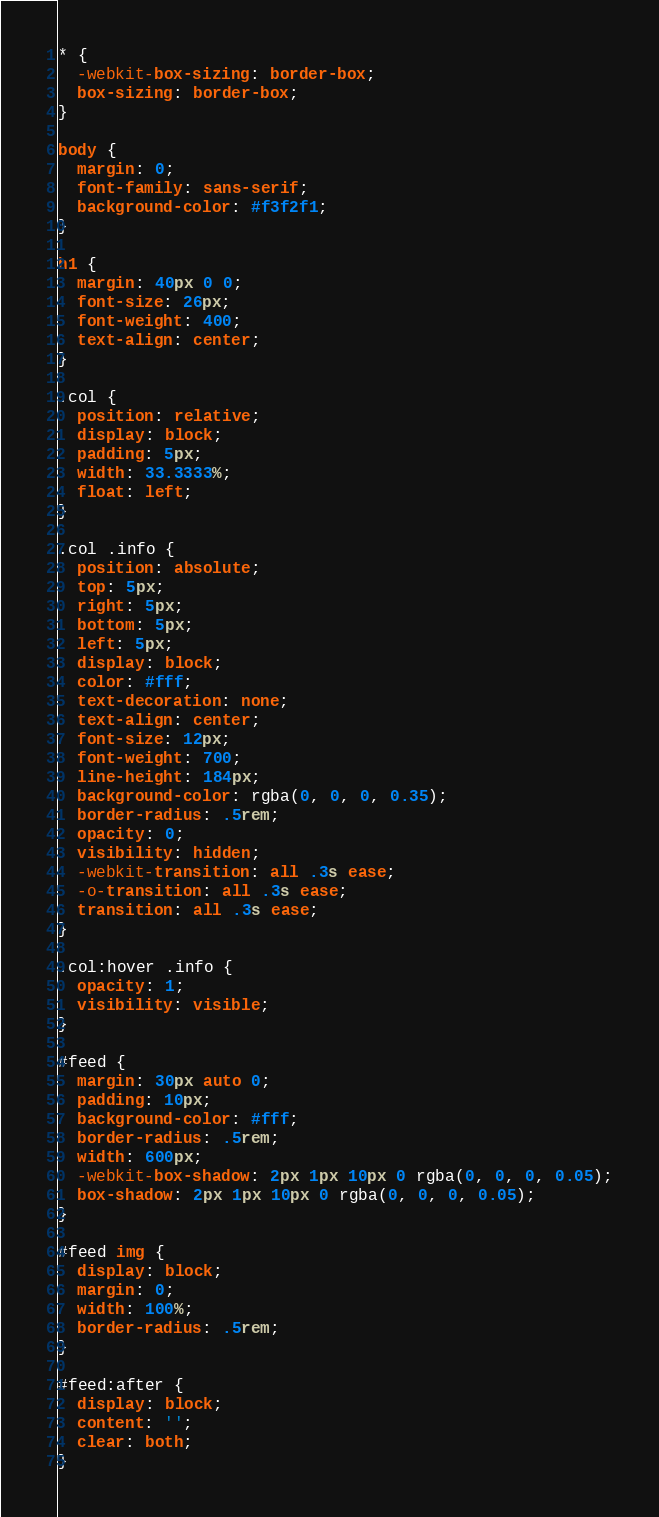Convert code to text. <code><loc_0><loc_0><loc_500><loc_500><_CSS_>* {
  -webkit-box-sizing: border-box;
  box-sizing: border-box;
}

body {
  margin: 0;
  font-family: sans-serif;
  background-color: #f3f2f1;
}

h1 {
  margin: 40px 0 0;
  font-size: 26px;
  font-weight: 400;
  text-align: center;
}

.col {
  position: relative;
  display: block;
  padding: 5px;
  width: 33.3333%;
  float: left;
}

.col .info {
  position: absolute;
  top: 5px;
  right: 5px;
  bottom: 5px;
  left: 5px;
  display: block;
  color: #fff;
  text-decoration: none;
  text-align: center;
  font-size: 12px;
  font-weight: 700;
  line-height: 184px;
  background-color: rgba(0, 0, 0, 0.35);
  border-radius: .5rem;
  opacity: 0;
  visibility: hidden;
  -webkit-transition: all .3s ease;
  -o-transition: all .3s ease;
  transition: all .3s ease;
}

.col:hover .info {
  opacity: 1;
  visibility: visible;
}

#feed {
  margin: 30px auto 0;
  padding: 10px;
  background-color: #fff;
  border-radius: .5rem;
  width: 600px;
  -webkit-box-shadow: 2px 1px 10px 0 rgba(0, 0, 0, 0.05);
  box-shadow: 2px 1px 10px 0 rgba(0, 0, 0, 0.05);
}

#feed img {
  display: block;
  margin: 0;
  width: 100%;
  border-radius: .5rem;
}

#feed:after {
  display: block;
  content: '';
  clear: both;
}
</code> 